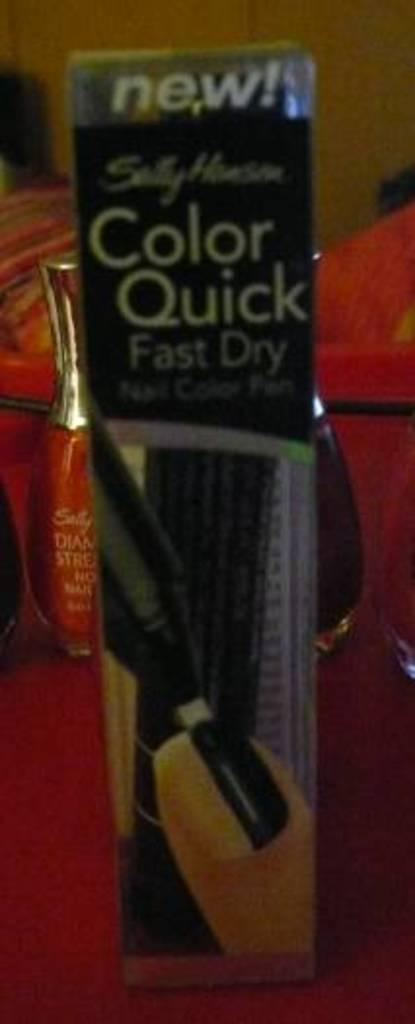<image>
Create a compact narrative representing the image presented. A close up of Color quick Fast dry mascara. 